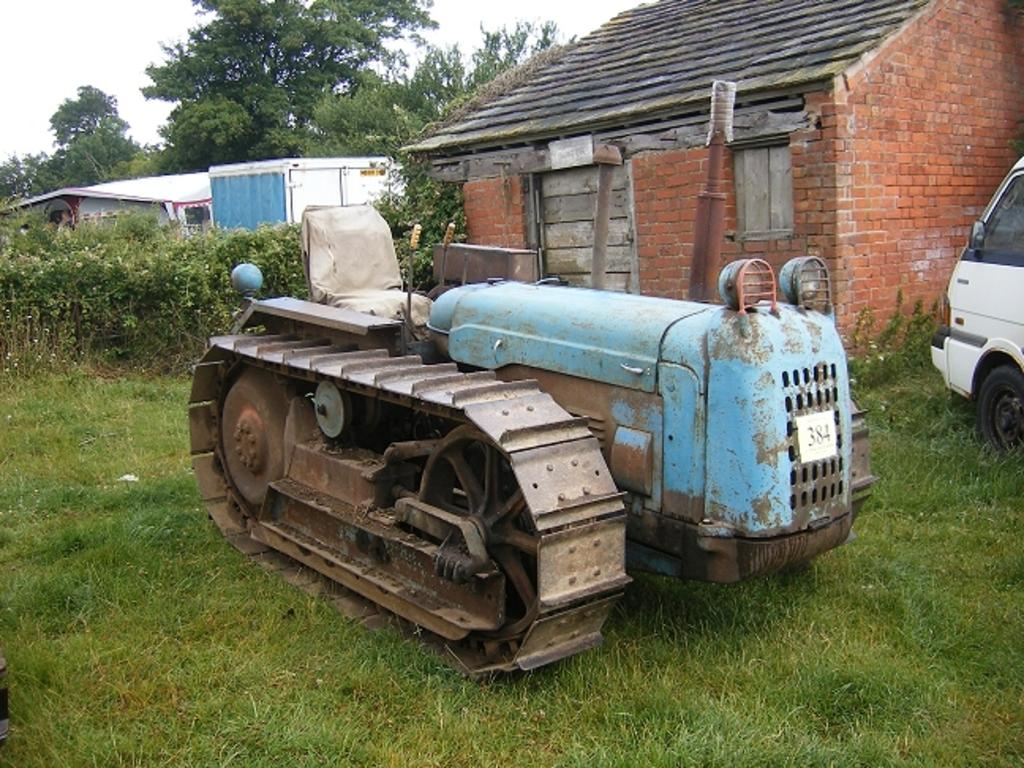What type of vehicle is in the image? There is a car in the image. Where is the car located in the image? The car is on the right side of the image. What type of vegetation is at the bottom of the image? There is grass at the bottom of the image. What structures can be seen in the background of the image? There is a house and trees in the background of the image. What type of sponge can be seen floating in the water near the seashore in the image? There is no seashore or sponge present in the image. What type of apparel is the person wearing while sitting on the car in the image? There is no person or apparel visible in the image; it only shows a car, grass, and structures in the background. 